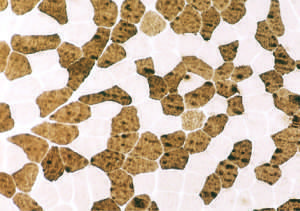did fibers on this atpase reaction ph9 .4 correspond to findings in the figure?
Answer the question using a single word or phrase. Yes 